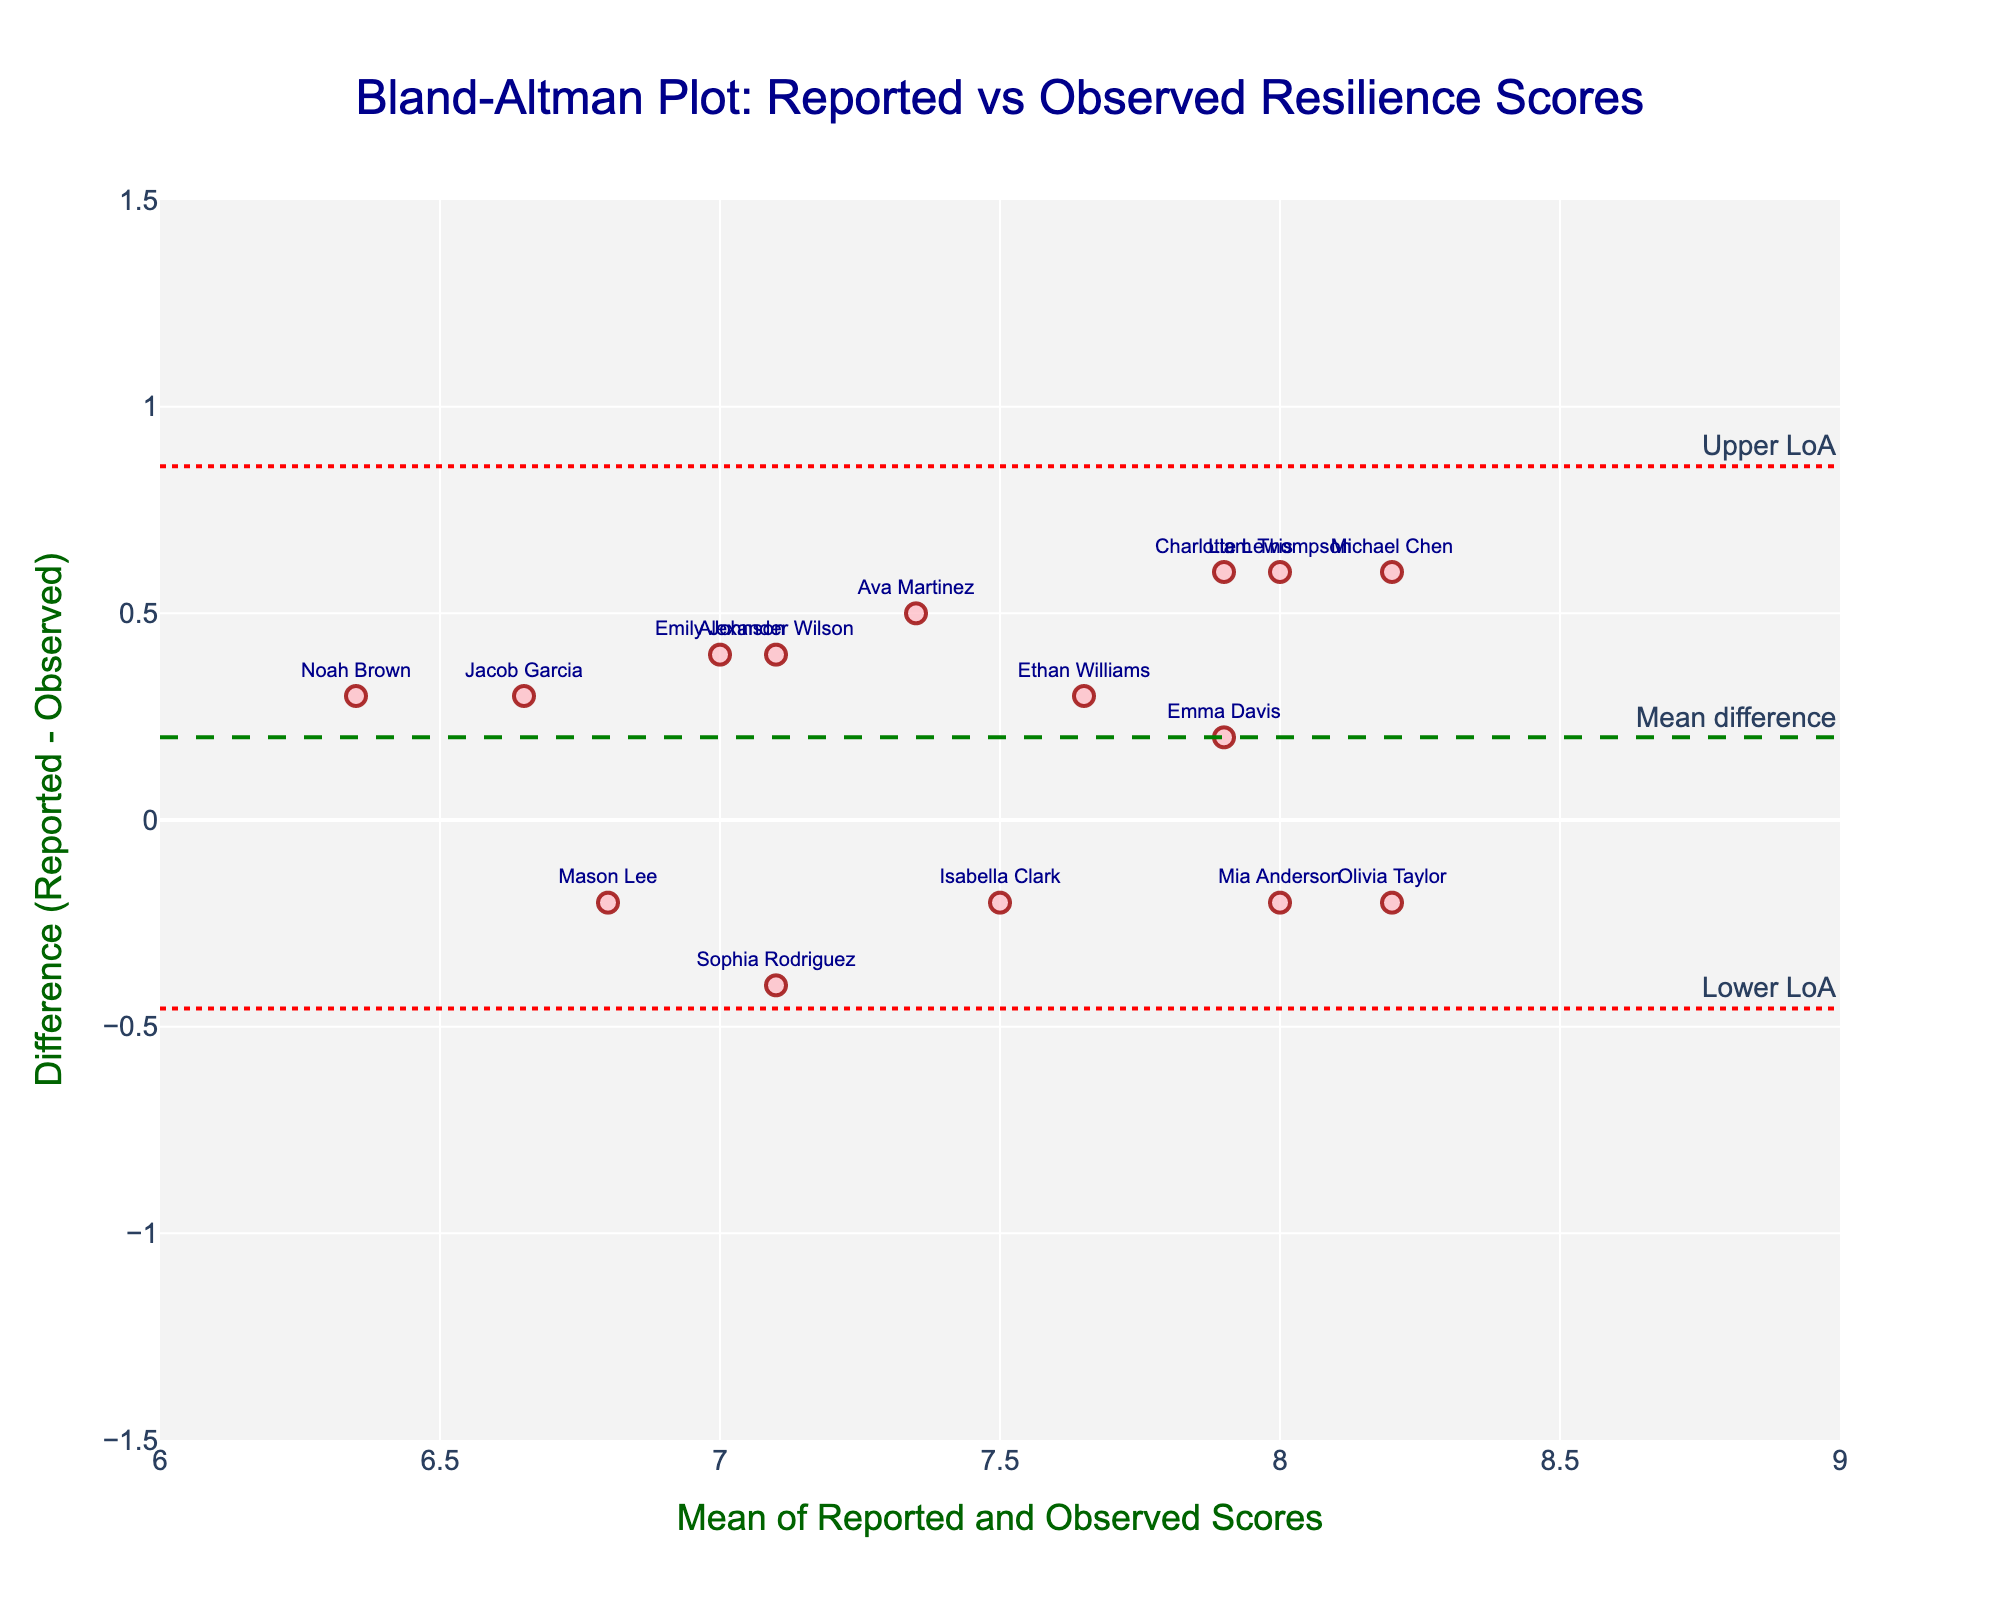What's the title of the plot? The title is usually displayed prominently at the top of the plot. In this case, the title is written in a larger font and is centered.
Answer: "Bland-Altman Plot: Reported vs Observed Resilience Scores" What do the x and y-axes represent on this plot? The x-axis and y-axis titles describe the variables plotted. The x-axis title states: "Mean of Reported and Observed Scores," while the y-axis title states: "Difference (Reported - Observed)."
Answer: The x-axis represents the mean of reported and observed resilience scores, and the y-axis represents the difference between reported and observed resilience scores How many students' data points are plotted? Each data point on the plot represents a student's resilience scores. There are 15 students listed in the data provided, corresponding to 15 data points on the plot.
Answer: 15 Which student has the highest mean resilience score? By checking the mean values plotted along the x-axis, find the highest value. Michael Chen has the highest x-axis value on the plot.
Answer: Michael Chen What is the mean difference between reported and observed resilience scores? The mean difference is represented by a dashed green line annotated as "Mean difference". Checking the value of this line on the plot gives the mean difference.
Answer: 0.08 What are the upper and lower limits of agreement? The upper and lower limits of agreement are shown as dotted red lines annotated on the plot. Checking these lines provides their values.
Answer: Upper: 0.44, Lower: -0.28 Which student shows the largest positive difference between reported and observed resilience scores? Identify the point with the greatest positive y-value because it indicates the largest positive difference. Olivia Taylor has the highest positive difference.
Answer: Olivia Taylor What is the range of the x-axis? The x-axis range can be found by looking at the limits set for the axis. The x-axis is from 6 to 9.
Answer: 6 to 9 Does the variation in differences suggest any bias in reported resilience scores? Analyzing the plot requires looking at how evenly the points are distributed around the mean difference line. If the points are scattered with no pattern and are relatively balanced around the mean difference, it suggests little to no bias. However, slight clustering or pattern may suggest a bias.
Answer: Some bias exists as points show slight variation but overall are reasonably scattered around the mean difference 